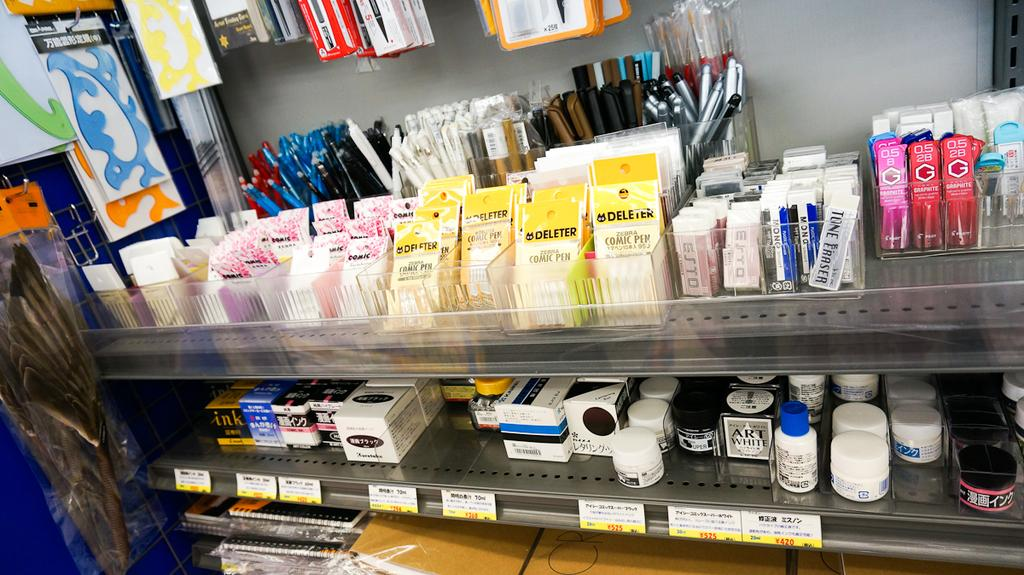<image>
Present a compact description of the photo's key features. Packs of Deleter for sale inside of a store. 